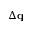<formula> <loc_0><loc_0><loc_500><loc_500>\Delta q</formula> 